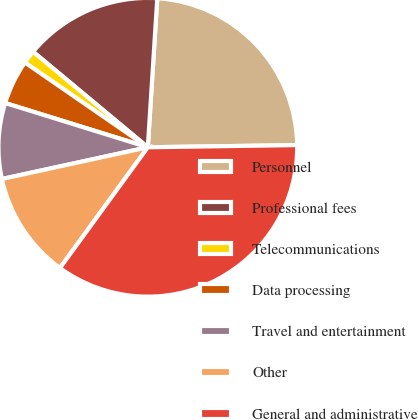<chart> <loc_0><loc_0><loc_500><loc_500><pie_chart><fcel>Personnel<fcel>Professional fees<fcel>Telecommunications<fcel>Data processing<fcel>Travel and entertainment<fcel>Other<fcel>General and administrative<nl><fcel>23.76%<fcel>14.96%<fcel>1.44%<fcel>4.82%<fcel>8.2%<fcel>11.58%<fcel>35.25%<nl></chart> 